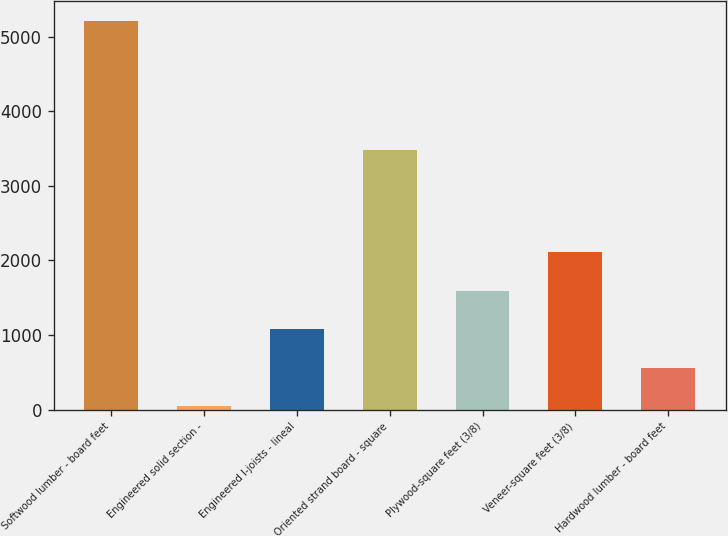Convert chart. <chart><loc_0><loc_0><loc_500><loc_500><bar_chart><fcel>Softwood lumber - board feet<fcel>Engineered solid section -<fcel>Engineered I-joists - lineal<fcel>Oriented strand board - square<fcel>Plywood-square feet (3/8)<fcel>Veneer-square feet (3/8)<fcel>Hardwood lumber - board feet<nl><fcel>5210<fcel>47<fcel>1079.6<fcel>3485<fcel>1595.9<fcel>2112.2<fcel>563.3<nl></chart> 